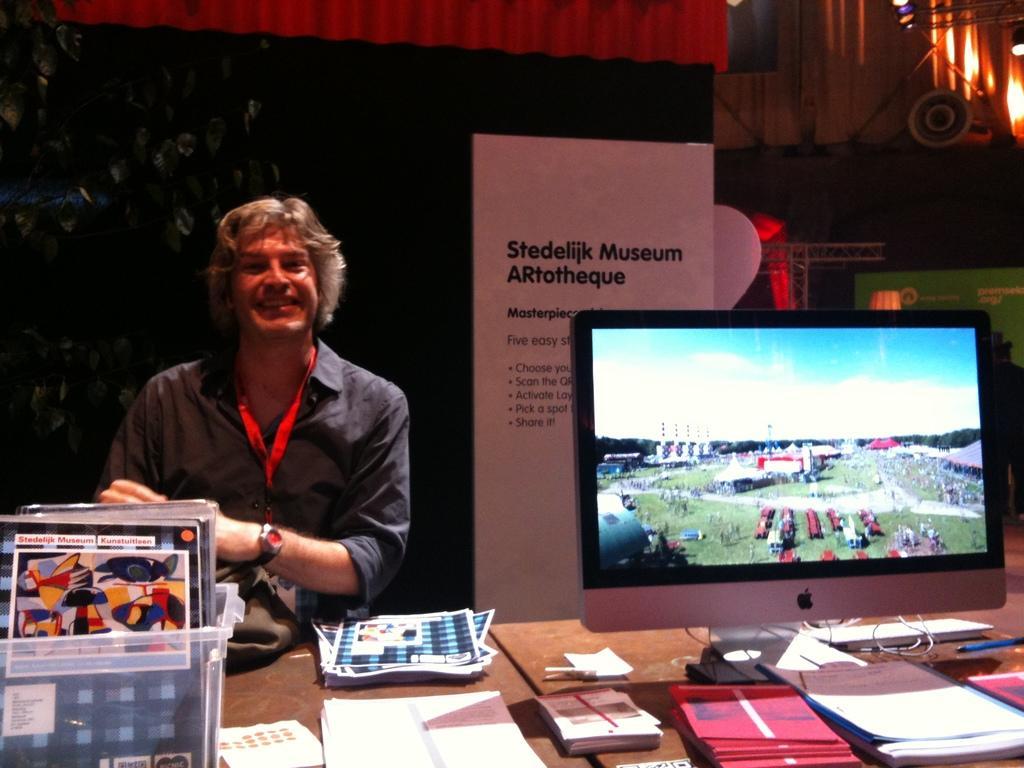Describe this image in one or two sentences. In this image I can see a person in front of a desk and on the desk I can see a plastic basket with few objects in it, few papers, few books and a monitor. In the background I can see few banners, few metal rods and few lights. 